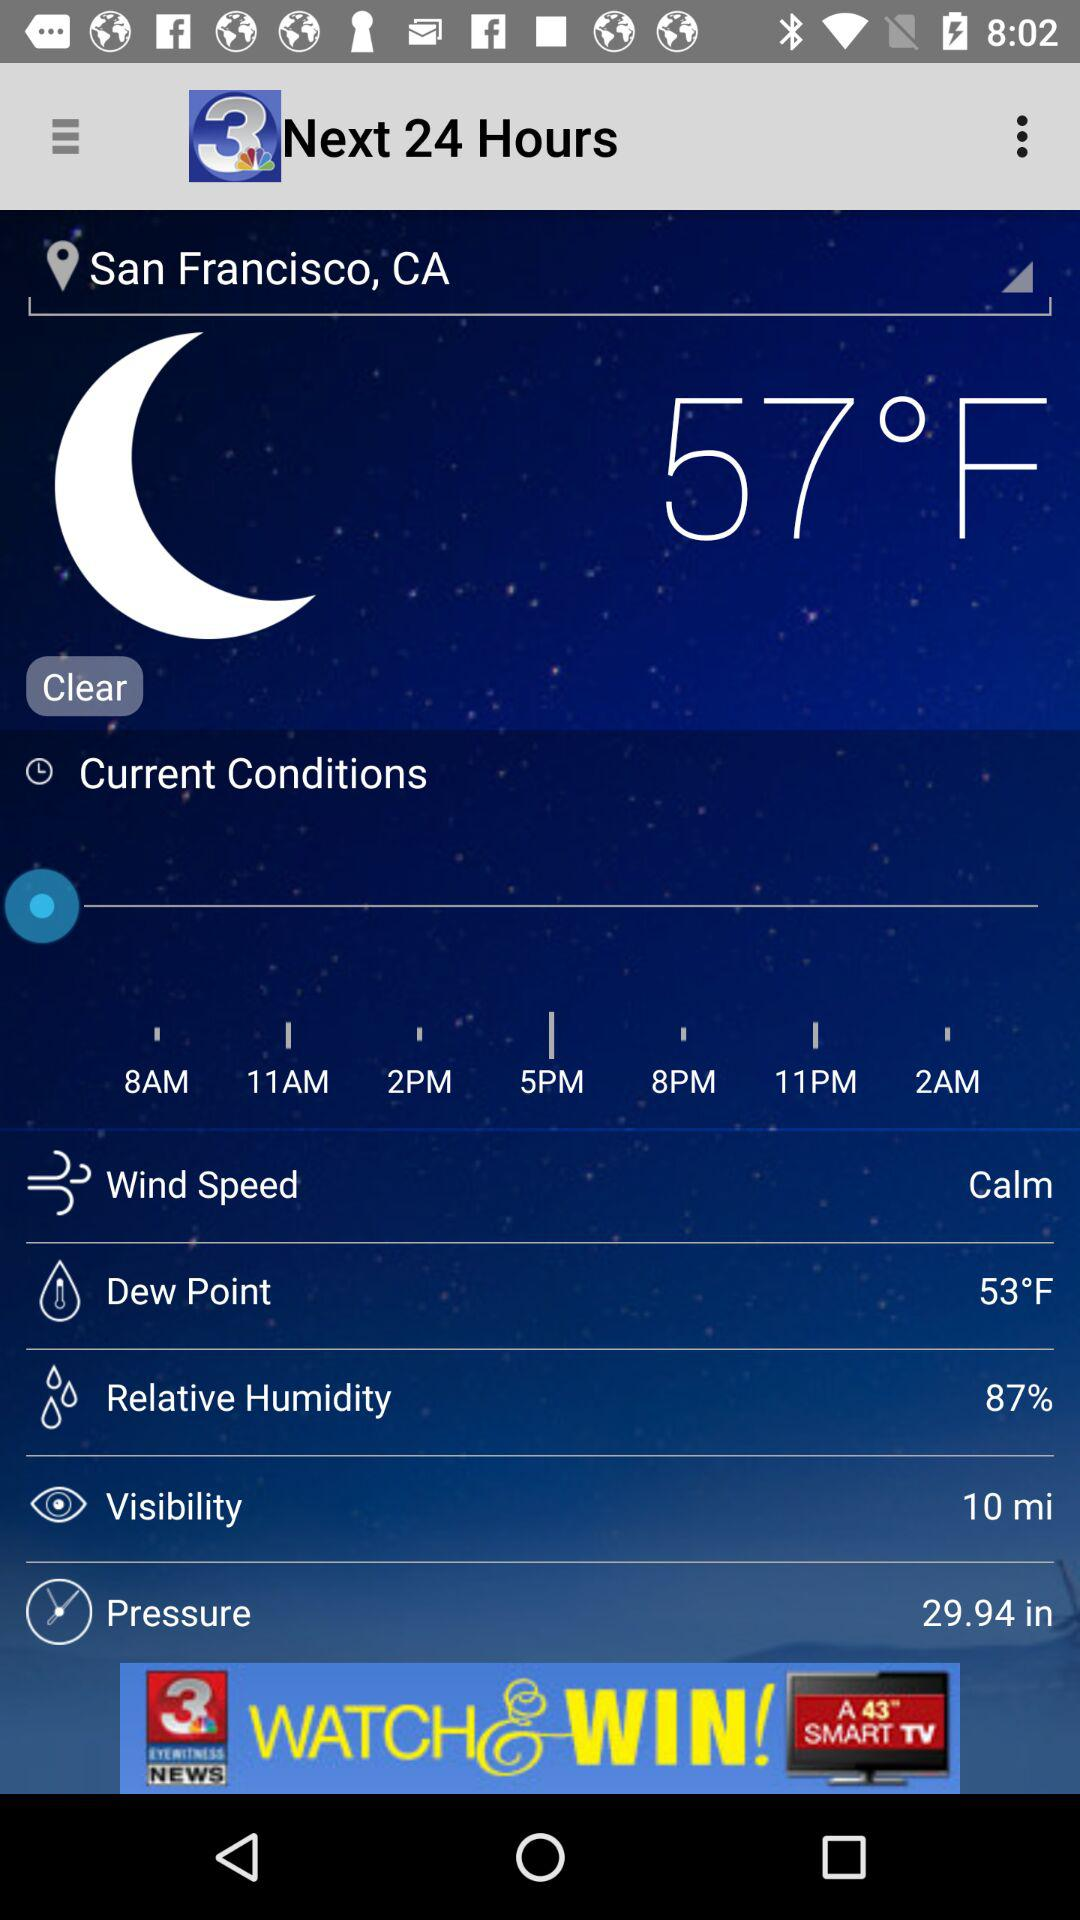How is the wind speed? The wind speed is calm. 